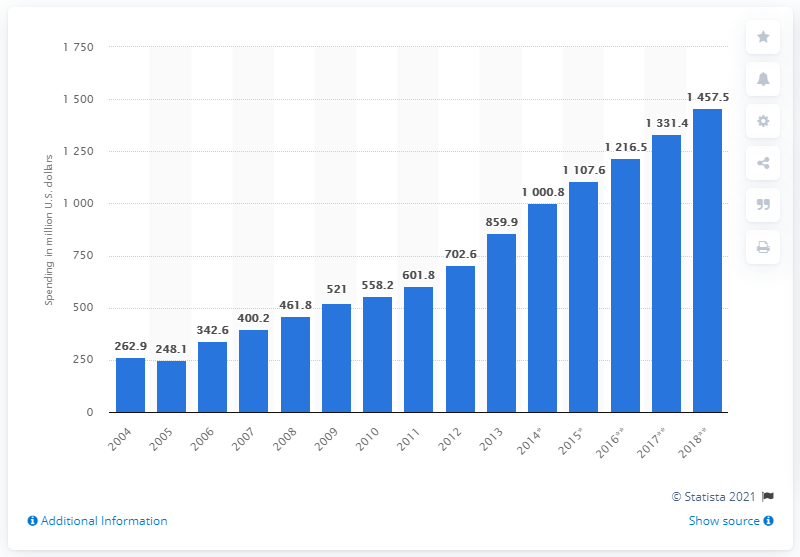What was the estimated ad expenditure in Vietnam in 2016? In 2016, the estimated advertisement expenditure in Vietnam was approximately 1,216.5 million US dollars, showing a noticeable increase from the previous years as depicted in the image of the bar chart. 